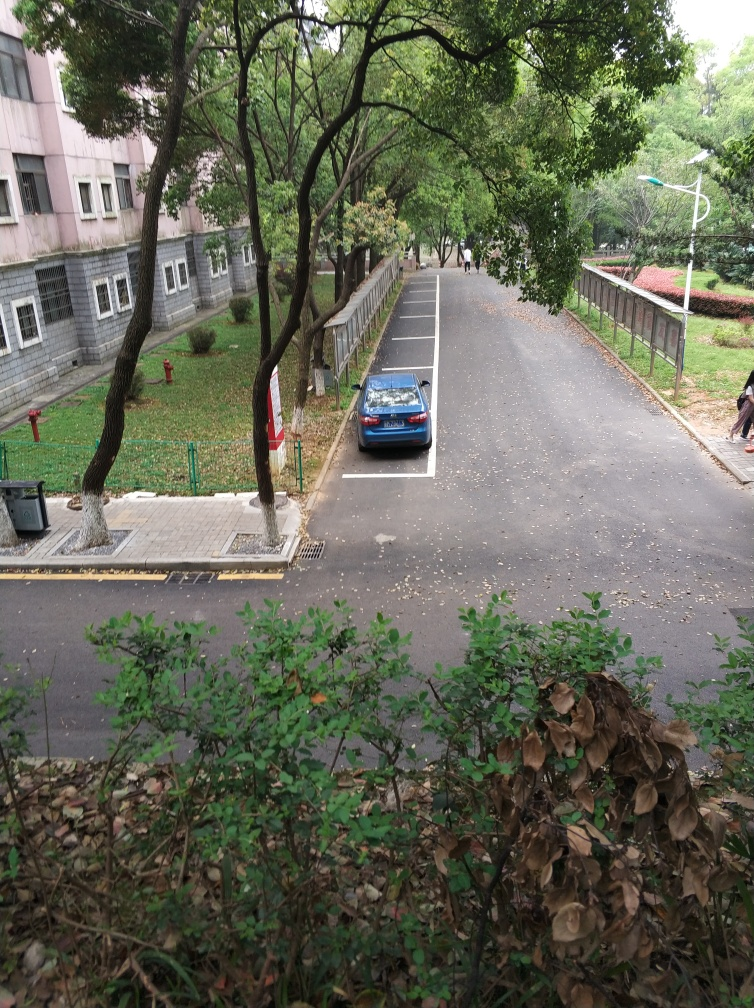Is the background of the image clear?
 Yes 